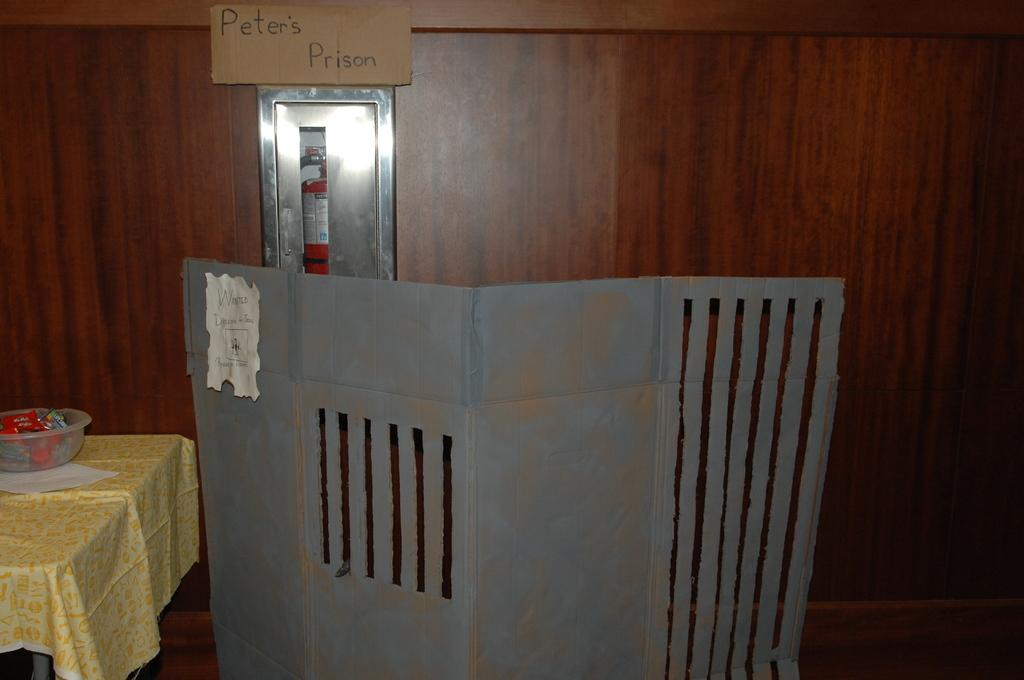<image>
Describe the image concisely. a sign says Peter's Prison above a cardboard prison gate 